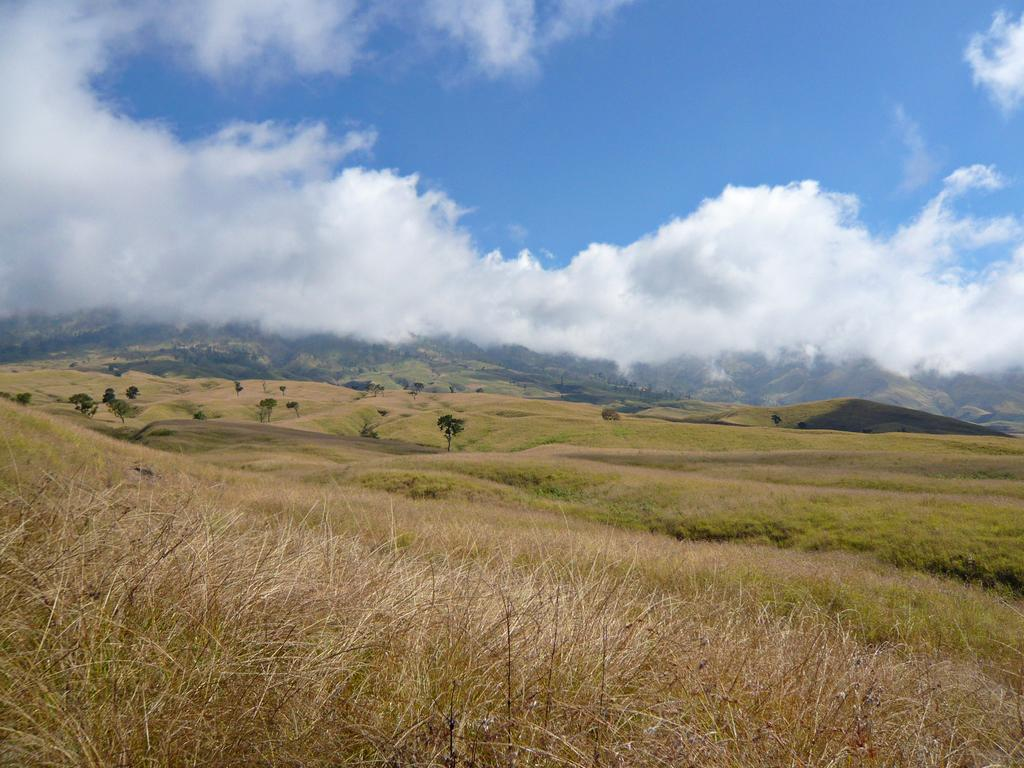What type of vegetation can be seen on the land in the image? There is dried grass on the land in the image. What other natural elements are present in the image? There are trees visible in the image. What can be seen in the distance in the image? There are hills visible in the background of the image. What is visible in the sky in the image? The sky is visible in the background of the image, and there are clouds present. Where is the wire connected to in the image? There is no wire present in the image. What is the drain used for in the image? There is no drain present in the image. 